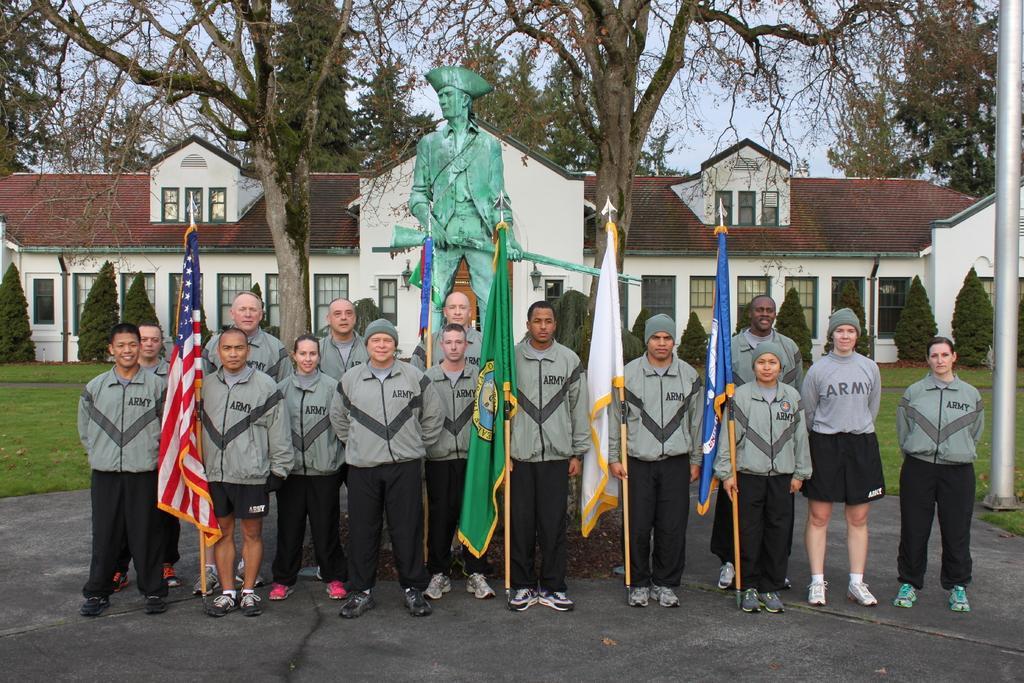How would you summarize this image in a sentence or two? In the image we can see there are people standing, wearing shoes and same of them are wearing clothes, some of them are wearing caps and they are smiling. Here we can see the flags, sculpture, grass and plants. Here we can see the house, windows, trees and the sky. 